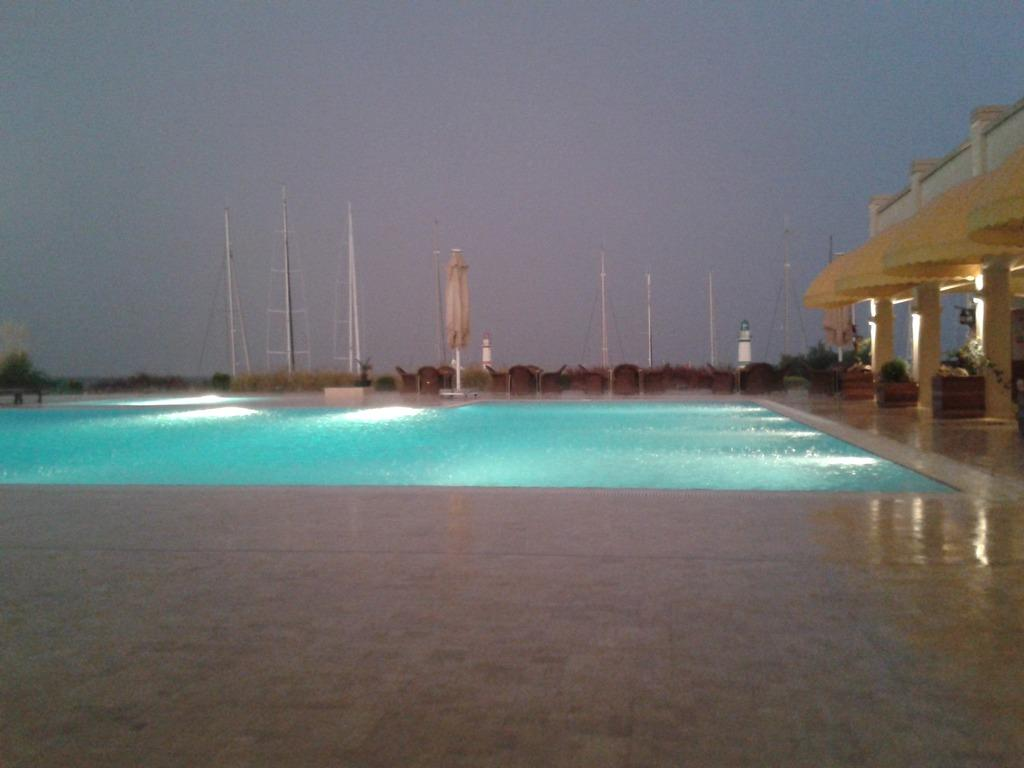What type of location is depicted in the image? The image appears to depict a resort. What recreational feature can be seen at the resort? There is a swimming pool in the image. What structures are visible behind the swimming pool? There are poles visible behind the swimming pool. Can you see a guitar being played by a beginner near the swimming pool in the image? There is no guitar or person playing it visible in the image. 